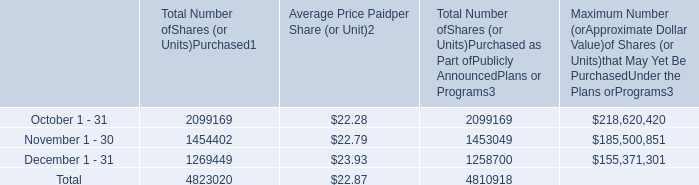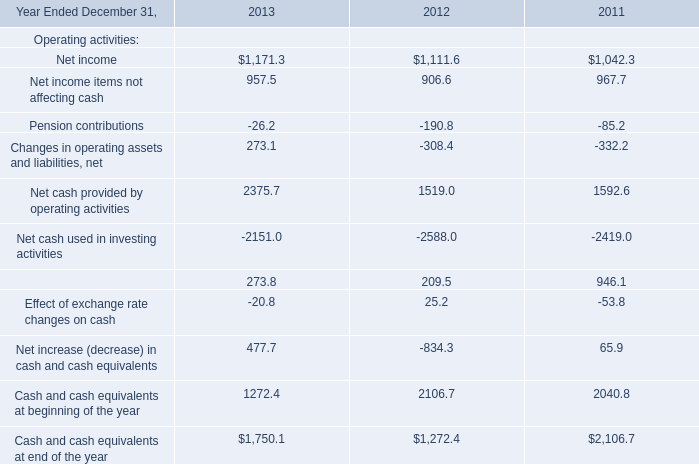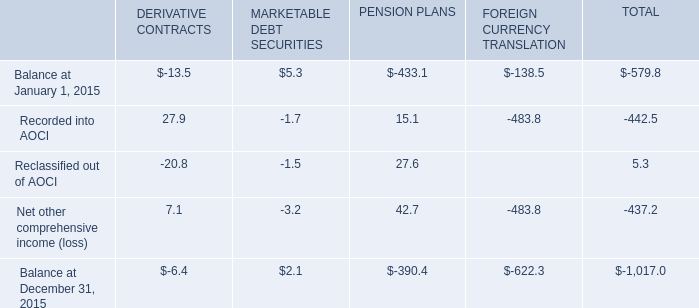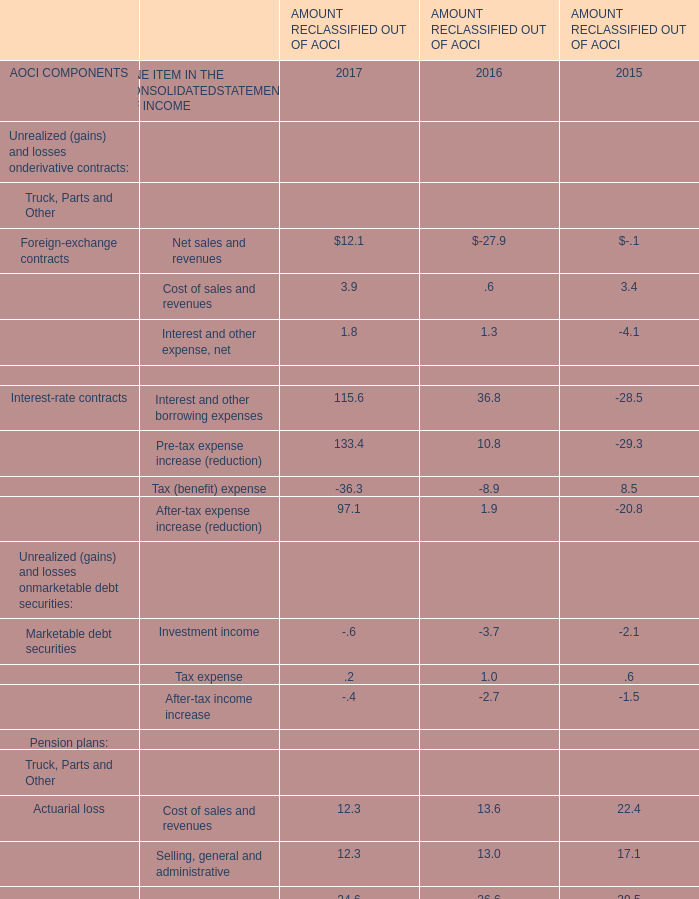Which year is Total reclassifications out of AOCI greater than 100? 
Answer: 2017. 